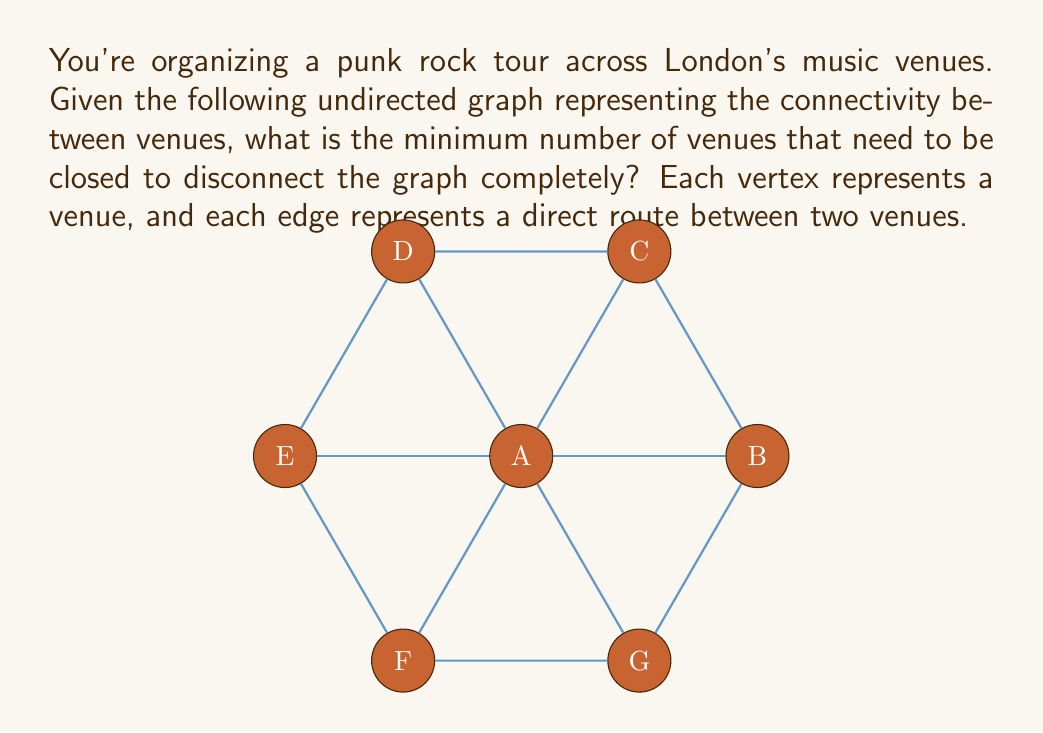Help me with this question. To solve this problem, we need to understand the concept of vertex connectivity in graph theory. The vertex connectivity of a graph is the minimum number of vertices that need to be removed to disconnect the graph.

Let's analyze the graph:

1. The graph has 7 vertices (A, B, C, D, E, F, G) representing music venues.
2. Each vertex is connected to at least 3 other vertices.
3. Vertex A is connected to all other vertices, making it a central hub.

To disconnect this graph, we need to remove enough vertices so that the remaining vertices are not all connected. Let's consider our options:

1. Removing vertex A disconnects the graph into 6 isolated vertices. This requires removing only 1 vertex.

2. If we don't remove A, we need to remove at least 3 vertices to disconnect the graph. For example:
   - Removing B, D, and F would disconnect the graph into two components: {A, C} and {A, E, G}.
   - Removing C, E, and G would have a similar effect.

3. Any combination of 2 vertices being removed will not disconnect the graph, as there will always be a path between the remaining vertices through A or the outer cycle.

Therefore, the minimum number of vertices that need to be removed (or venues closed) to disconnect the graph is 1, which is achieved by removing vertex A.

This solution reflects the punk rock spirit of the tour organizer, as it identifies the most crucial venue (the "hub" of the punk scene) whose closure would have the most significant impact on the tour's connectivity.
Answer: 1 venue 